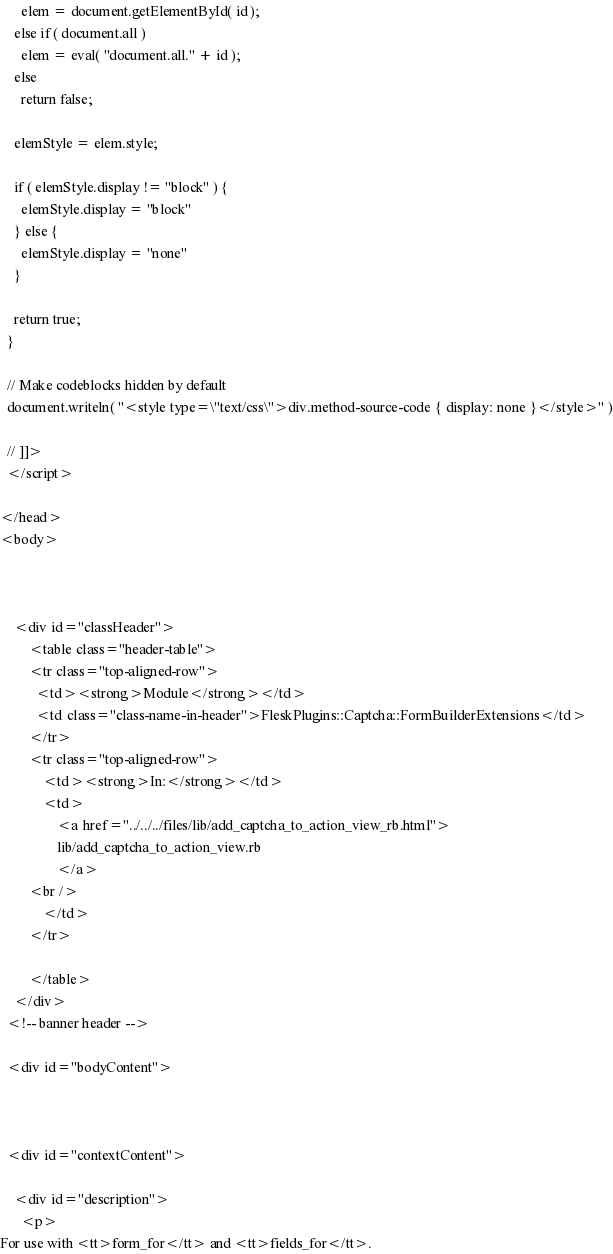Convert code to text. <code><loc_0><loc_0><loc_500><loc_500><_HTML_>      elem = document.getElementById( id );
    else if ( document.all )
      elem = eval( "document.all." + id );
    else
      return false;

    elemStyle = elem.style;
    
    if ( elemStyle.display != "block" ) {
      elemStyle.display = "block"
    } else {
      elemStyle.display = "none"
    }

    return true;
  }
  
  // Make codeblocks hidden by default
  document.writeln( "<style type=\"text/css\">div.method-source-code { display: none }</style>" )
  
  // ]]>
  </script>

</head>
<body>



    <div id="classHeader">
        <table class="header-table">
        <tr class="top-aligned-row">
          <td><strong>Module</strong></td>
          <td class="class-name-in-header">FleskPlugins::Captcha::FormBuilderExtensions</td>
        </tr>
        <tr class="top-aligned-row">
            <td><strong>In:</strong></td>
            <td>
                <a href="../../../files/lib/add_captcha_to_action_view_rb.html">
                lib/add_captcha_to_action_view.rb
                </a>
        <br />
            </td>
        </tr>

        </table>
    </div>
  <!-- banner header -->

  <div id="bodyContent">



  <div id="contextContent">

    <div id="description">
      <p>
For use with <tt>form_for</tt> and <tt>fields_for</tt>.</code> 